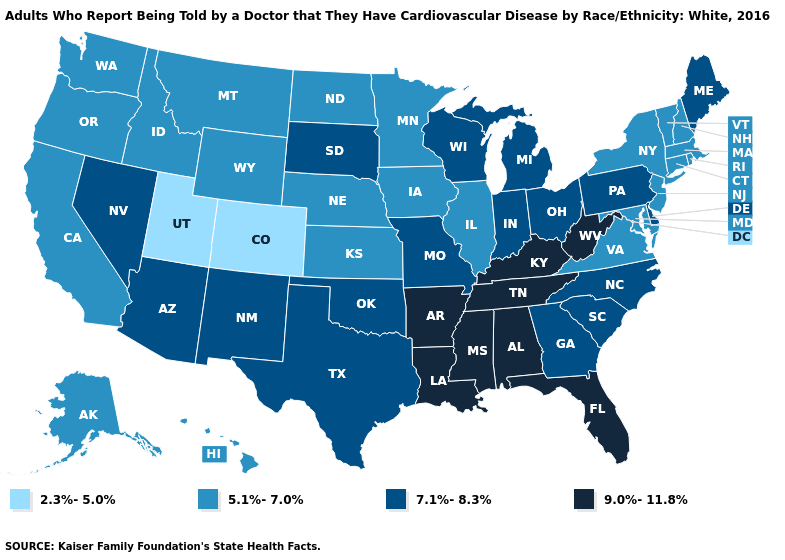Which states have the lowest value in the USA?
Be succinct. Colorado, Utah. What is the value of Maryland?
Write a very short answer. 5.1%-7.0%. Which states have the lowest value in the USA?
Answer briefly. Colorado, Utah. How many symbols are there in the legend?
Concise answer only. 4. What is the value of Nebraska?
Write a very short answer. 5.1%-7.0%. What is the value of New Hampshire?
Be succinct. 5.1%-7.0%. What is the value of Delaware?
Give a very brief answer. 7.1%-8.3%. What is the value of Mississippi?
Concise answer only. 9.0%-11.8%. Which states hav the highest value in the West?
Write a very short answer. Arizona, Nevada, New Mexico. Does the first symbol in the legend represent the smallest category?
Answer briefly. Yes. Name the states that have a value in the range 7.1%-8.3%?
Give a very brief answer. Arizona, Delaware, Georgia, Indiana, Maine, Michigan, Missouri, Nevada, New Mexico, North Carolina, Ohio, Oklahoma, Pennsylvania, South Carolina, South Dakota, Texas, Wisconsin. Does the map have missing data?
Write a very short answer. No. What is the value of Colorado?
Answer briefly. 2.3%-5.0%. Does North Carolina have the highest value in the South?
Quick response, please. No. Does New York have the highest value in the Northeast?
Write a very short answer. No. 